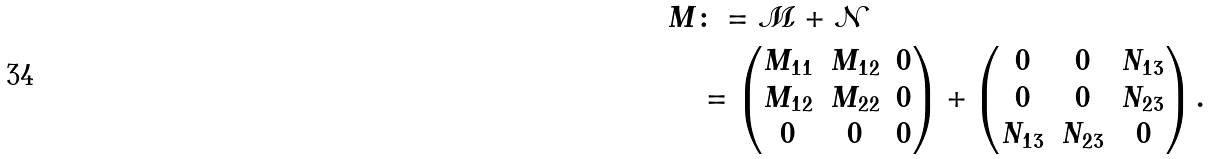Convert formula to latex. <formula><loc_0><loc_0><loc_500><loc_500>M & \colon = { \mathcal { M } } + { \mathcal { N } } \\ & = \left ( \begin{matrix} M _ { 1 1 } & M _ { 1 2 } & 0 \\ M _ { 1 2 } & M _ { 2 2 } & 0 \\ 0 & 0 & 0 \end{matrix} \right ) + \left ( \begin{matrix} 0 & 0 & N _ { 1 3 } \\ 0 & 0 & N _ { 2 3 } \\ N _ { 1 3 } & N _ { 2 3 } & 0 \end{matrix} \right ) .</formula> 